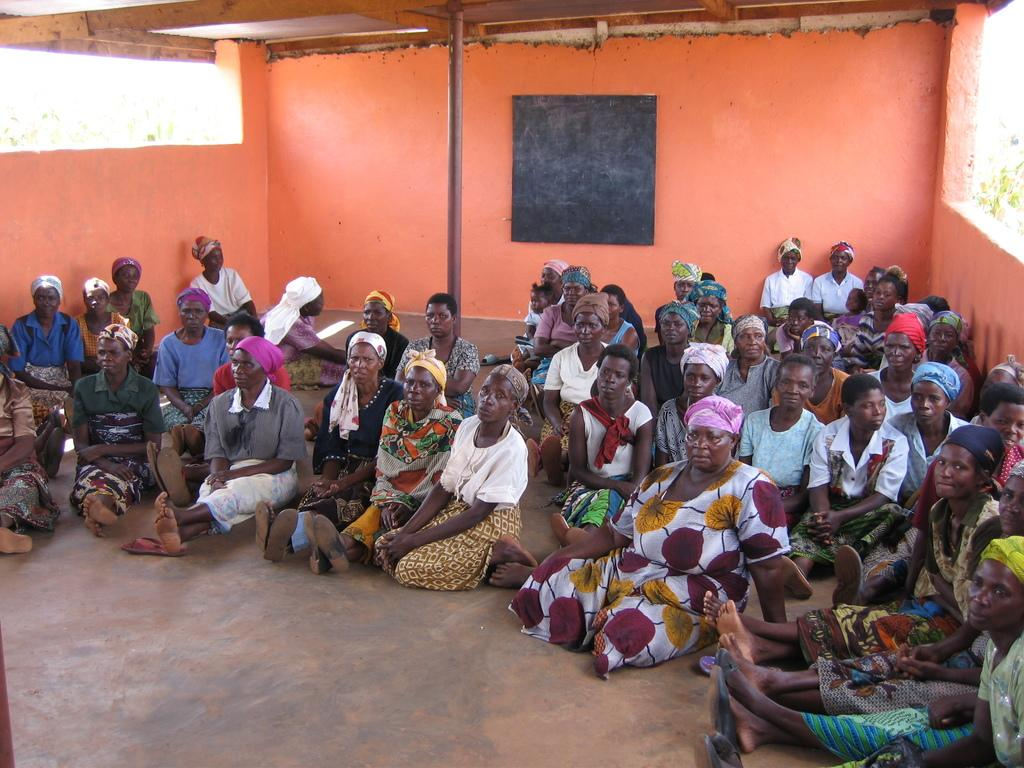What are the people in the image doing? The people are sitting on the floor in the image. Where are the people located? The people are in a room. What can be seen on the wall in the background of the image? There is a board attached to the wall in the background of the image. What grade did the person receive on their amusement park wristband in the image? There is no amusement park wristband or grade mentioned in the image. 